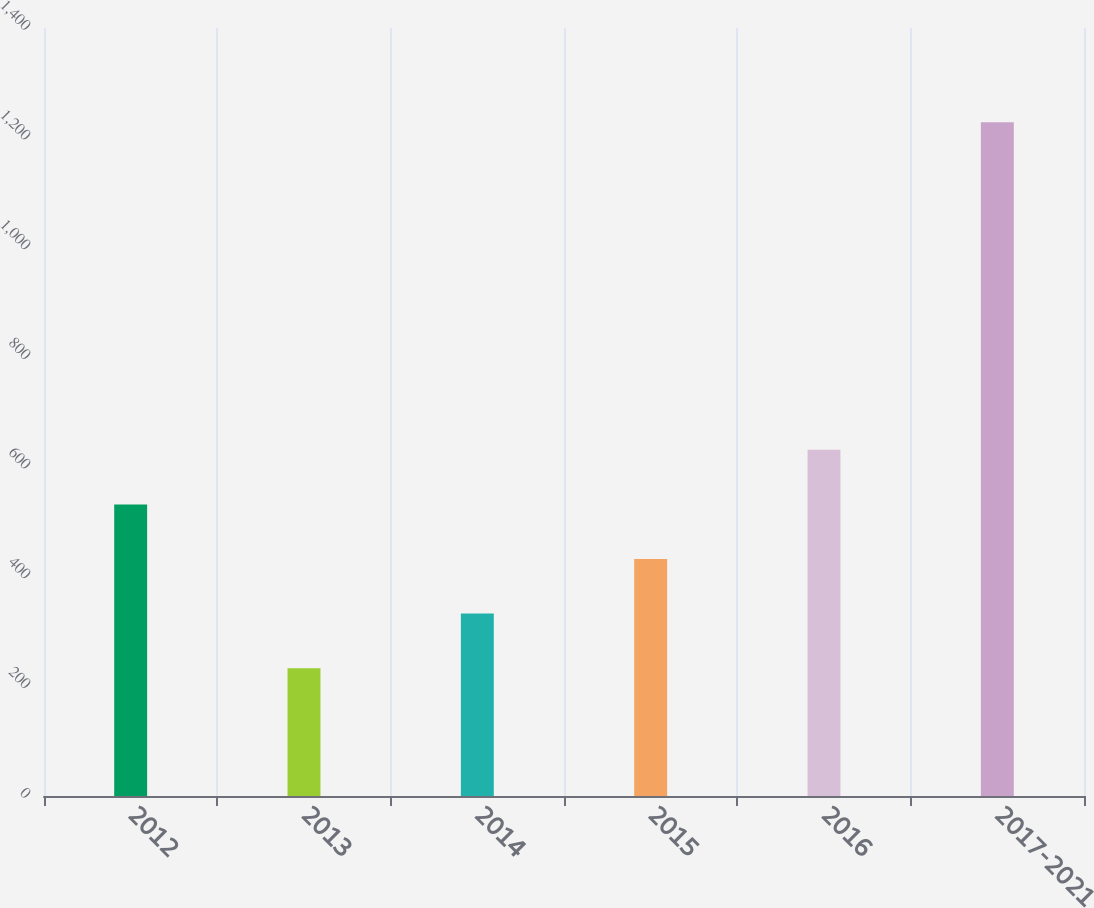Convert chart to OTSL. <chart><loc_0><loc_0><loc_500><loc_500><bar_chart><fcel>2012<fcel>2013<fcel>2014<fcel>2015<fcel>2016<fcel>2017-2021<nl><fcel>531.5<fcel>233<fcel>332.5<fcel>432<fcel>631<fcel>1228<nl></chart> 